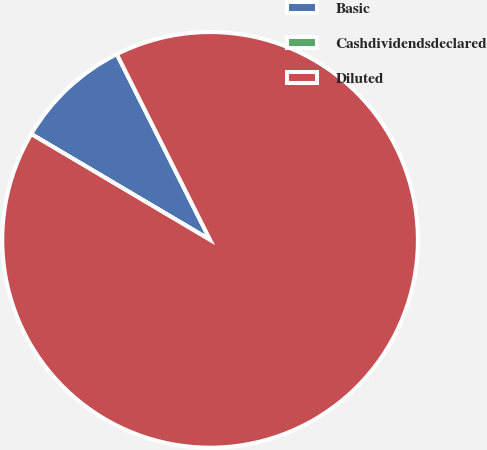Convert chart. <chart><loc_0><loc_0><loc_500><loc_500><pie_chart><fcel>Basic<fcel>Cashdividendsdeclared<fcel>Diluted<nl><fcel>9.09%<fcel>0.0%<fcel>90.91%<nl></chart> 